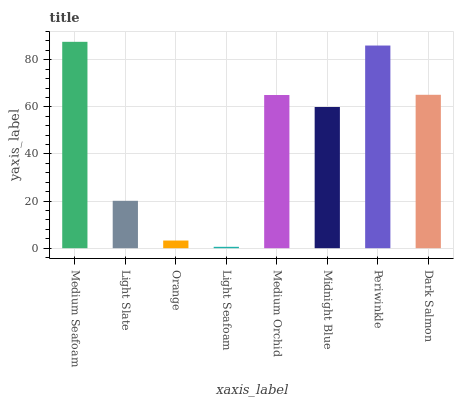Is Light Seafoam the minimum?
Answer yes or no. Yes. Is Medium Seafoam the maximum?
Answer yes or no. Yes. Is Light Slate the minimum?
Answer yes or no. No. Is Light Slate the maximum?
Answer yes or no. No. Is Medium Seafoam greater than Light Slate?
Answer yes or no. Yes. Is Light Slate less than Medium Seafoam?
Answer yes or no. Yes. Is Light Slate greater than Medium Seafoam?
Answer yes or no. No. Is Medium Seafoam less than Light Slate?
Answer yes or no. No. Is Medium Orchid the high median?
Answer yes or no. Yes. Is Midnight Blue the low median?
Answer yes or no. Yes. Is Orange the high median?
Answer yes or no. No. Is Light Slate the low median?
Answer yes or no. No. 